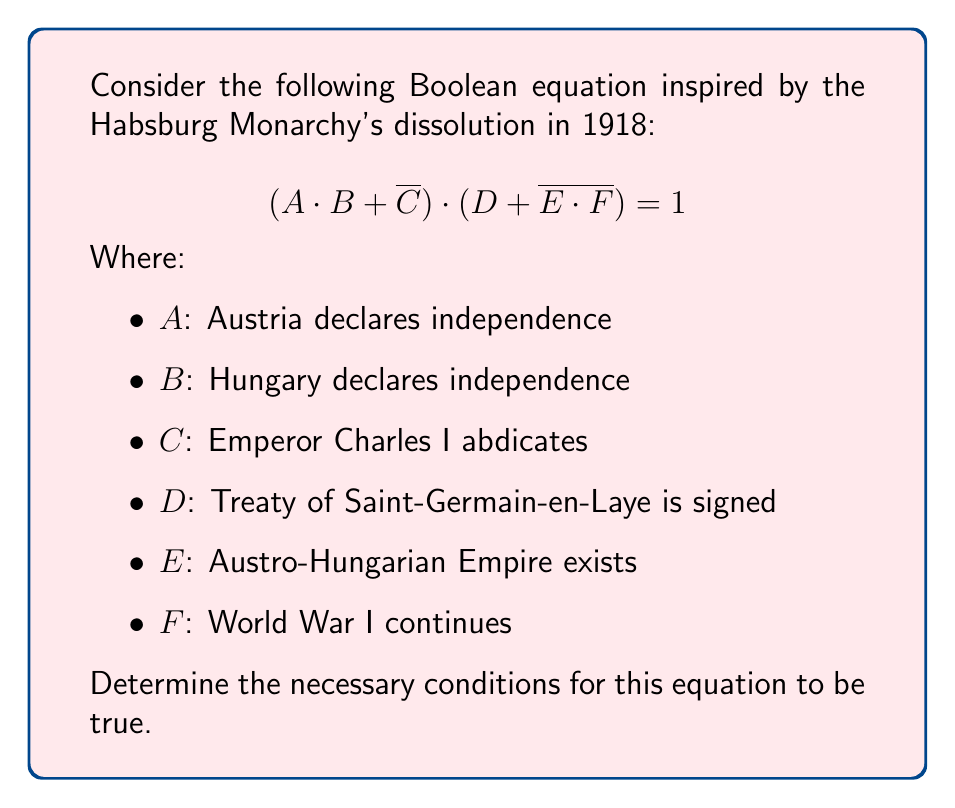What is the answer to this math problem? Let's approach this step-by-step:

1) For the entire equation to be true (1), both parts of the AND operation must be true:
   $$(A \cdot B + \overline{C}) = 1$$ and $$(D + \overline{E \cdot F}) = 1$$

2) Let's examine the first part: $(A \cdot B + \overline{C}) = 1$
   This is true if either $A \cdot B = 1$ or $\overline{C} = 1$ (or both)
   
   - If $A \cdot B = 1$, then both A and B must be 1 (Austria and Hungary declare independence)
   - If $\overline{C} = 1$, then C must be 0 (Emperor Charles I does not abdicate)

3) Now, let's look at the second part: $(D + \overline{E \cdot F}) = 1$
   This is true if either $D = 1$ or $\overline{E \cdot F} = 1$ (or both)
   
   - If $D = 1$, the Treaty of Saint-Germain-en-Laye is signed
   - If $\overline{E \cdot F} = 1$, then $E \cdot F = 0$, which means either $E = 0$ or $F = 0$ (or both)
     - $E = 0$: Austro-Hungarian Empire does not exist
     - $F = 0$: World War I does not continue

4) Combining these conditions, we have two possible scenarios:
   a) A = 1, B = 1, D = 1 (independence declarations and treaty signing)
   b) C = 0, E = 0 or F = 0 (no abdication, and either empire dissolved or war ended)

Therefore, the necessary conditions are: either Austria and Hungary declare independence and the treaty is signed, or the Emperor doesn't abdicate and either the empire is dissolved or the war ends.
Answer: $(A \wedge B \wedge D) \vee (\neg C \wedge (\neg E \vee \neg F))$ 